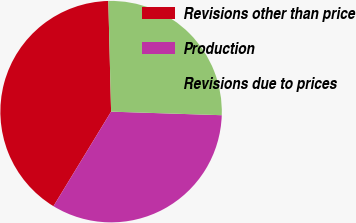<chart> <loc_0><loc_0><loc_500><loc_500><pie_chart><fcel>Revisions other than price<fcel>Production<fcel>Revisions due to prices<nl><fcel>40.89%<fcel>33.2%<fcel>25.91%<nl></chart> 